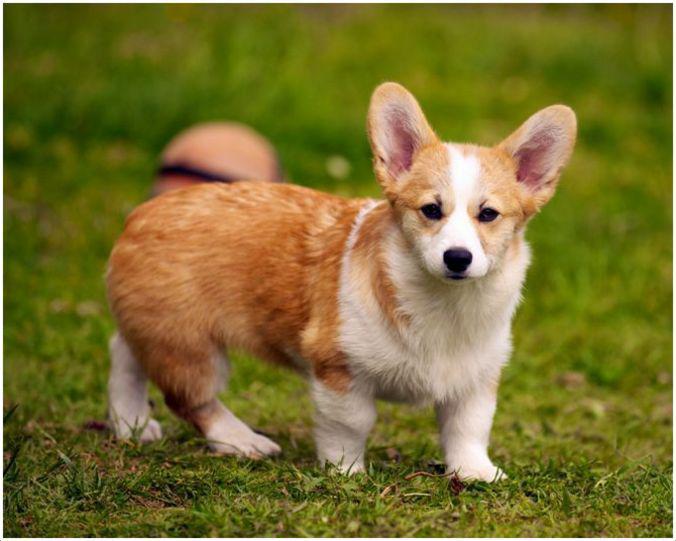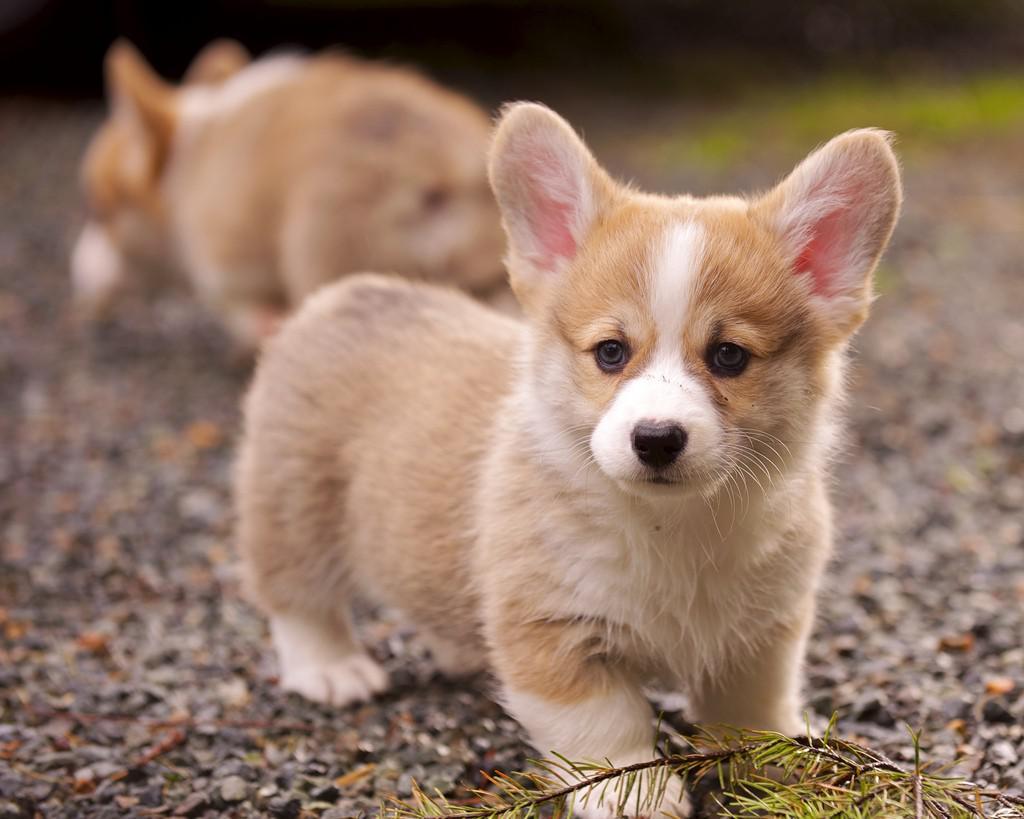The first image is the image on the left, the second image is the image on the right. Analyze the images presented: Is the assertion "There is a dog in the left image standing on grass." valid? Answer yes or no. Yes. 